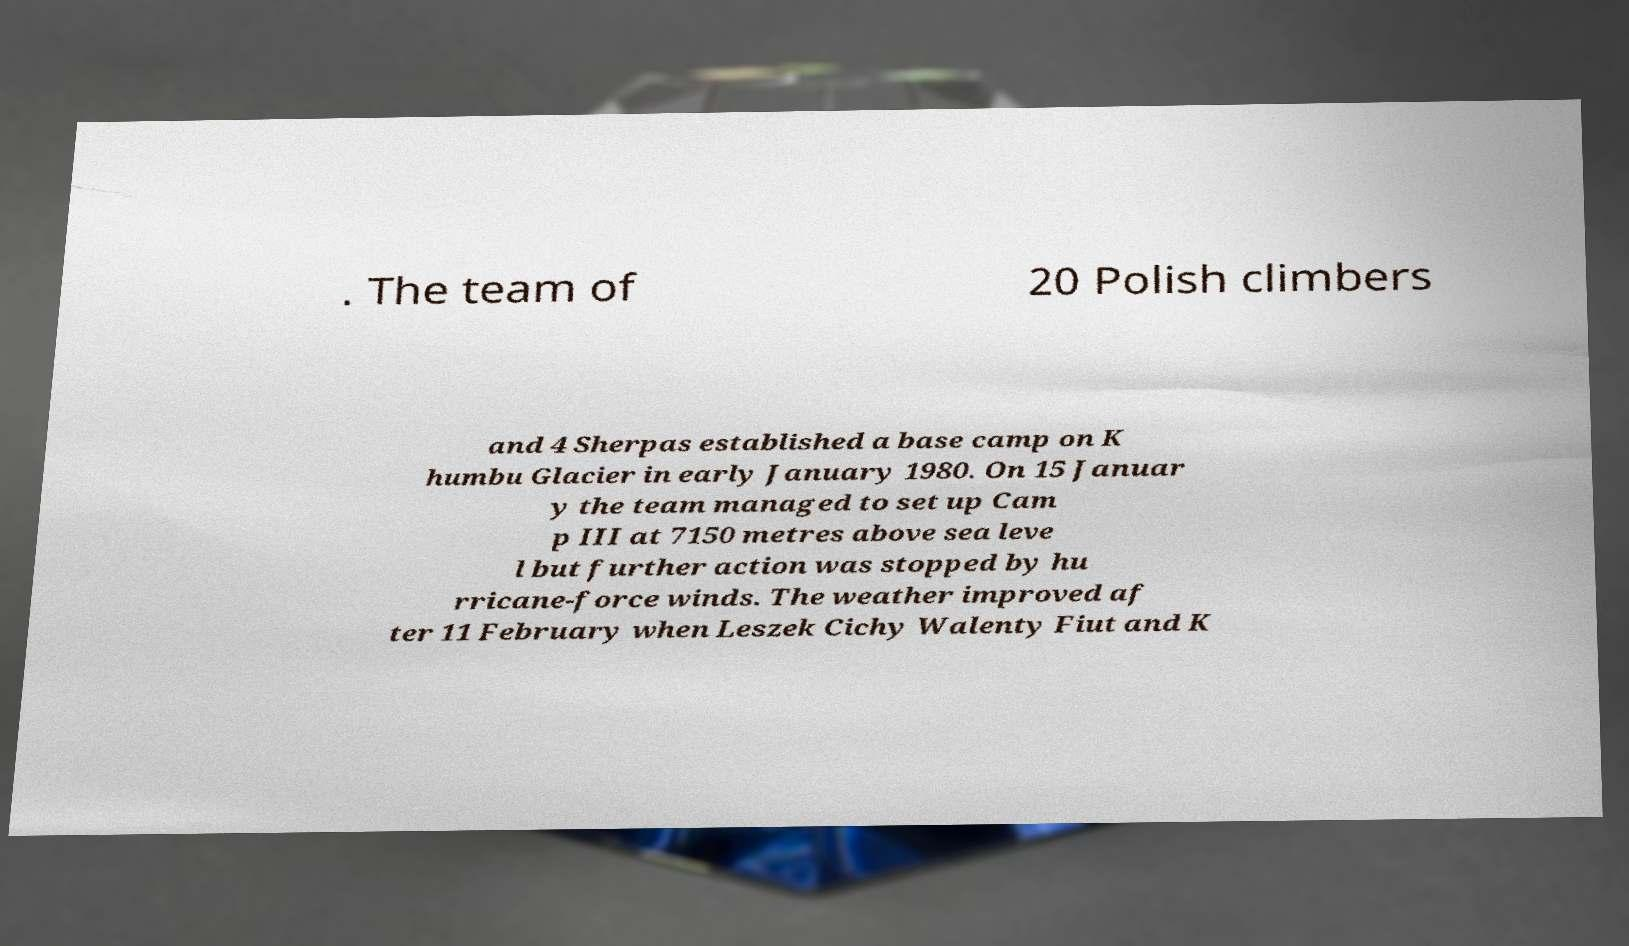Could you extract and type out the text from this image? . The team of 20 Polish climbers and 4 Sherpas established a base camp on K humbu Glacier in early January 1980. On 15 Januar y the team managed to set up Cam p III at 7150 metres above sea leve l but further action was stopped by hu rricane-force winds. The weather improved af ter 11 February when Leszek Cichy Walenty Fiut and K 